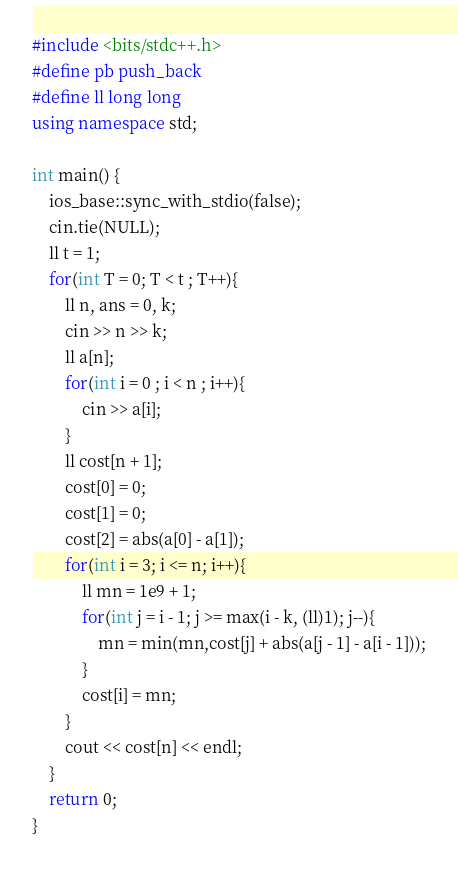Convert code to text. <code><loc_0><loc_0><loc_500><loc_500><_C++_>#include <bits/stdc++.h>
#define pb push_back
#define ll long long 
using namespace std;

int main() {
    ios_base::sync_with_stdio(false);
    cin.tie(NULL);
    ll t = 1; 
    for(int T = 0; T < t ; T++){
        ll n, ans = 0, k;
        cin >> n >> k;
        ll a[n];
        for(int i = 0 ; i < n ; i++){
            cin >> a[i];
        }
        ll cost[n + 1];
        cost[0] = 0;
        cost[1] = 0;
        cost[2] = abs(a[0] - a[1]);
        for(int i = 3; i <= n; i++){
            ll mn = 1e9 + 1;
            for(int j = i - 1; j >= max(i - k, (ll)1); j--){
                mn = min(mn,cost[j] + abs(a[j - 1] - a[i - 1]));
            }
            cost[i] = mn;
        }
        cout << cost[n] << endl;
    }
    return 0;
}</code> 